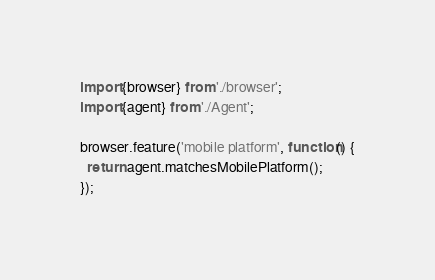<code> <loc_0><loc_0><loc_500><loc_500><_JavaScript_>import {browser} from './browser';
import {agent} from './Agent';

browser.feature('mobile platform', function() {
  return agent.matchesMobilePlatform();
});
</code> 